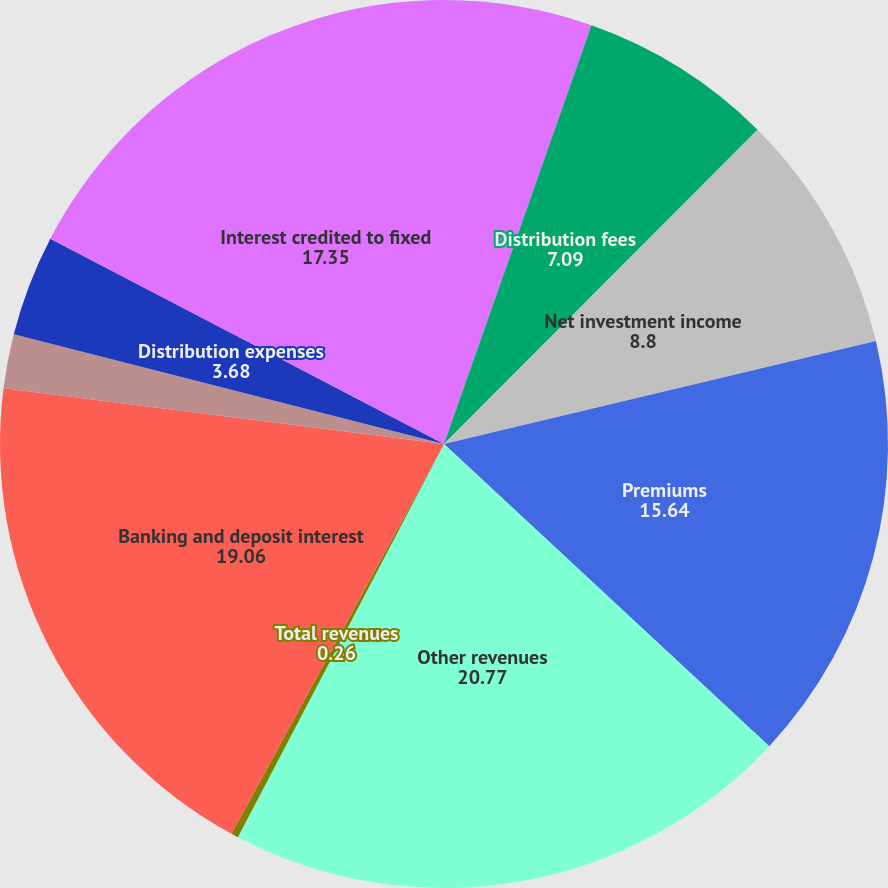Convert chart to OTSL. <chart><loc_0><loc_0><loc_500><loc_500><pie_chart><fcel>Management and financial<fcel>Distribution fees<fcel>Net investment income<fcel>Premiums<fcel>Other revenues<fcel>Total revenues<fcel>Banking and deposit interest<fcel>Total net revenues<fcel>Distribution expenses<fcel>Interest credited to fixed<nl><fcel>5.39%<fcel>7.09%<fcel>8.8%<fcel>15.64%<fcel>20.77%<fcel>0.26%<fcel>19.06%<fcel>1.97%<fcel>3.68%<fcel>17.35%<nl></chart> 